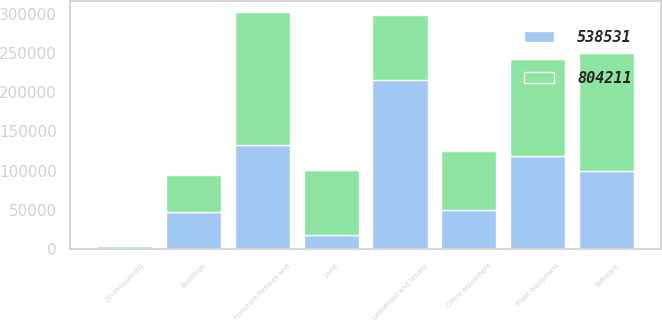Convert chart. <chart><loc_0><loc_0><loc_500><loc_500><stacked_bar_chart><ecel><fcel>(In thousands)<fcel>Leasehold and tenant<fcel>Furniture fixtures and<fcel>Buildings<fcel>Software<fcel>Office equipment<fcel>Plant equipment<fcel>Land<nl><fcel>804211<fcel>2016<fcel>83574<fcel>168720<fcel>47216<fcel>151059<fcel>75196<fcel>124140<fcel>83574<nl><fcel>538531<fcel>2015<fcel>214834<fcel>132736<fcel>47137<fcel>99309<fcel>50399<fcel>118138<fcel>17628<nl></chart> 